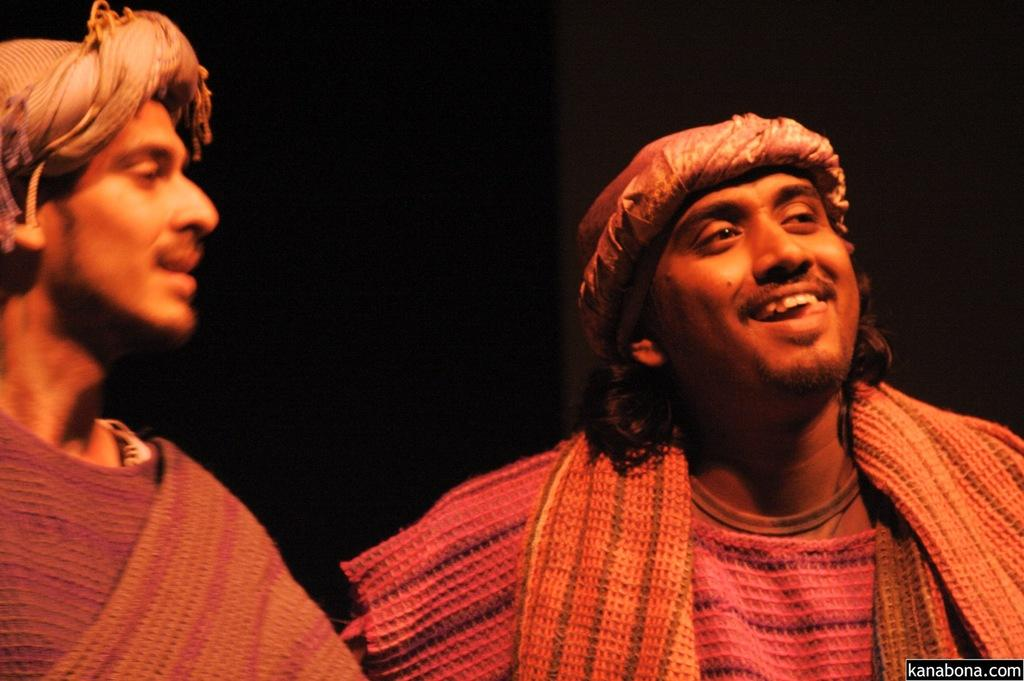How many people are in the image? There are two men in the image. What is the facial expression of one of the men? One of the men is smiling. What can be observed about the background of the image? The background of the image is dark. What type of statement is being made by the flag in the image? There is no flag present in the image, so no statement can be made by a flag. 